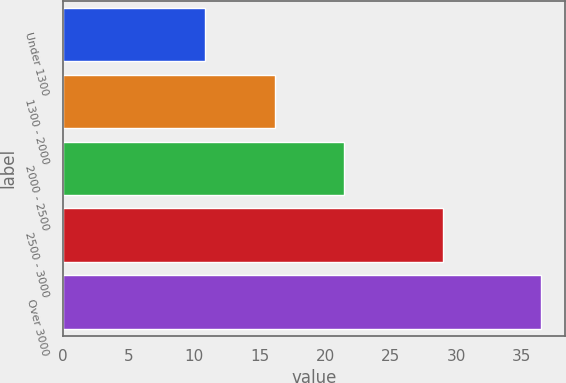Convert chart. <chart><loc_0><loc_0><loc_500><loc_500><bar_chart><fcel>Under 1300<fcel>1300 - 2000<fcel>2000 - 2500<fcel>2500 - 3000<fcel>Over 3000<nl><fcel>10.85<fcel>16.19<fcel>21.46<fcel>28.97<fcel>36.45<nl></chart> 